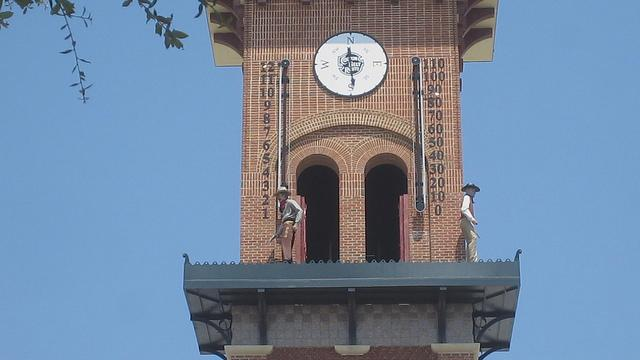What is the device shown in the image? clock 